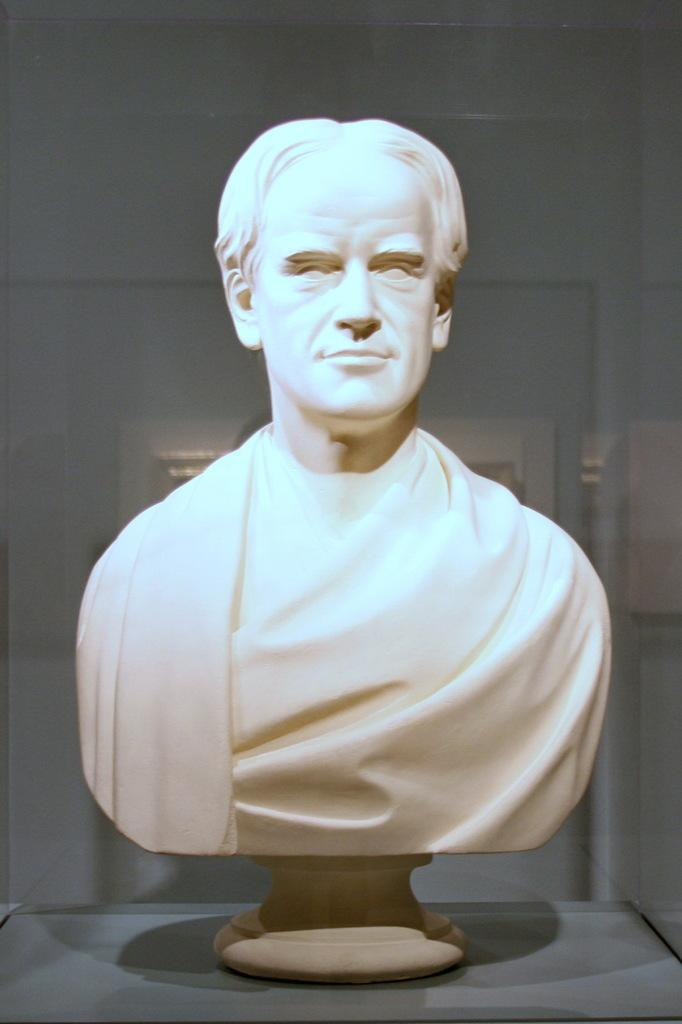What is the main subject of the image? The main subject of the image is a statue of a man. Where is the statue placed in the image? The statue is placed on a box. What type of yarn is being used to create the veins in the statue's relation to the box? There is no yarn or veins present in the image, and the statue's relation to the box is simply that it is placed on top of it. 